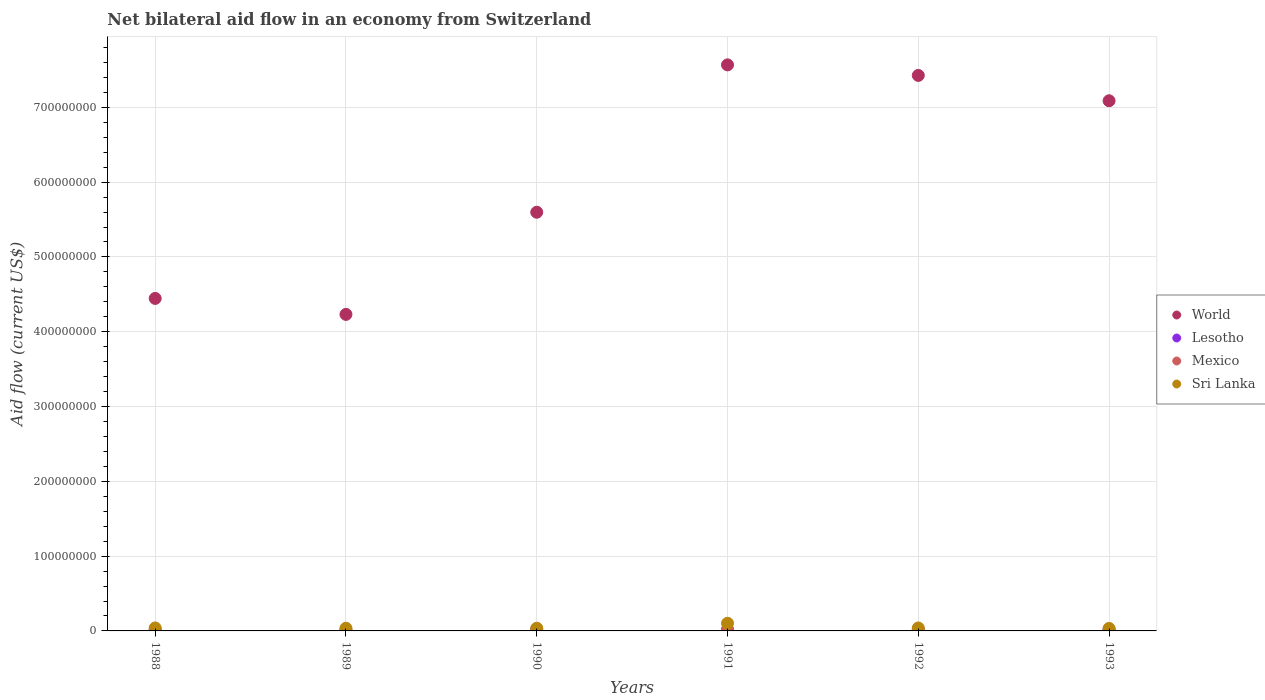How many different coloured dotlines are there?
Your response must be concise. 4. What is the net bilateral aid flow in Lesotho in 1989?
Make the answer very short. 8.60e+05. Across all years, what is the maximum net bilateral aid flow in Mexico?
Your answer should be very brief. 9.10e+05. What is the total net bilateral aid flow in World in the graph?
Provide a short and direct response. 3.64e+09. What is the difference between the net bilateral aid flow in Sri Lanka in 1991 and that in 1992?
Give a very brief answer. 6.31e+06. What is the difference between the net bilateral aid flow in World in 1993 and the net bilateral aid flow in Lesotho in 1989?
Offer a very short reply. 7.08e+08. What is the average net bilateral aid flow in World per year?
Provide a short and direct response. 6.06e+08. In the year 1993, what is the difference between the net bilateral aid flow in Mexico and net bilateral aid flow in World?
Your response must be concise. -7.09e+08. In how many years, is the net bilateral aid flow in Sri Lanka greater than 460000000 US$?
Give a very brief answer. 0. What is the ratio of the net bilateral aid flow in World in 1990 to that in 1993?
Your response must be concise. 0.79. Is the net bilateral aid flow in Sri Lanka in 1989 less than that in 1993?
Offer a very short reply. No. What is the difference between the highest and the lowest net bilateral aid flow in Sri Lanka?
Give a very brief answer. 6.93e+06. Is the sum of the net bilateral aid flow in Sri Lanka in 1988 and 1989 greater than the maximum net bilateral aid flow in Lesotho across all years?
Your answer should be compact. Yes. Is it the case that in every year, the sum of the net bilateral aid flow in Sri Lanka and net bilateral aid flow in Lesotho  is greater than the net bilateral aid flow in World?
Your answer should be compact. No. Is the net bilateral aid flow in Mexico strictly greater than the net bilateral aid flow in Sri Lanka over the years?
Offer a very short reply. No. Does the graph contain any zero values?
Make the answer very short. No. Where does the legend appear in the graph?
Your answer should be very brief. Center right. What is the title of the graph?
Make the answer very short. Net bilateral aid flow in an economy from Switzerland. What is the label or title of the X-axis?
Your response must be concise. Years. What is the label or title of the Y-axis?
Your response must be concise. Aid flow (current US$). What is the Aid flow (current US$) in World in 1988?
Your answer should be very brief. 4.45e+08. What is the Aid flow (current US$) in Lesotho in 1988?
Provide a succinct answer. 1.59e+06. What is the Aid flow (current US$) of Mexico in 1988?
Give a very brief answer. 4.80e+05. What is the Aid flow (current US$) of Sri Lanka in 1988?
Provide a short and direct response. 3.97e+06. What is the Aid flow (current US$) of World in 1989?
Make the answer very short. 4.23e+08. What is the Aid flow (current US$) in Lesotho in 1989?
Make the answer very short. 8.60e+05. What is the Aid flow (current US$) in Mexico in 1989?
Your answer should be compact. 8.80e+05. What is the Aid flow (current US$) in Sri Lanka in 1989?
Your answer should be very brief. 3.58e+06. What is the Aid flow (current US$) of World in 1990?
Give a very brief answer. 5.60e+08. What is the Aid flow (current US$) of Mexico in 1990?
Offer a very short reply. 9.10e+05. What is the Aid flow (current US$) in Sri Lanka in 1990?
Ensure brevity in your answer.  3.61e+06. What is the Aid flow (current US$) in World in 1991?
Offer a very short reply. 7.57e+08. What is the Aid flow (current US$) in Lesotho in 1991?
Offer a terse response. 1.99e+06. What is the Aid flow (current US$) in Mexico in 1991?
Offer a terse response. 3.40e+05. What is the Aid flow (current US$) in Sri Lanka in 1991?
Your answer should be compact. 1.02e+07. What is the Aid flow (current US$) of World in 1992?
Offer a terse response. 7.43e+08. What is the Aid flow (current US$) in Lesotho in 1992?
Your answer should be compact. 2.06e+06. What is the Aid flow (current US$) of Mexico in 1992?
Keep it short and to the point. 2.10e+05. What is the Aid flow (current US$) in Sri Lanka in 1992?
Provide a short and direct response. 3.94e+06. What is the Aid flow (current US$) in World in 1993?
Ensure brevity in your answer.  7.09e+08. What is the Aid flow (current US$) in Lesotho in 1993?
Provide a succinct answer. 2.02e+06. What is the Aid flow (current US$) in Sri Lanka in 1993?
Offer a terse response. 3.32e+06. Across all years, what is the maximum Aid flow (current US$) in World?
Provide a short and direct response. 7.57e+08. Across all years, what is the maximum Aid flow (current US$) of Lesotho?
Keep it short and to the point. 2.06e+06. Across all years, what is the maximum Aid flow (current US$) of Mexico?
Your response must be concise. 9.10e+05. Across all years, what is the maximum Aid flow (current US$) in Sri Lanka?
Offer a terse response. 1.02e+07. Across all years, what is the minimum Aid flow (current US$) of World?
Make the answer very short. 4.23e+08. Across all years, what is the minimum Aid flow (current US$) of Lesotho?
Your response must be concise. 8.60e+05. Across all years, what is the minimum Aid flow (current US$) of Sri Lanka?
Your answer should be compact. 3.32e+06. What is the total Aid flow (current US$) of World in the graph?
Make the answer very short. 3.64e+09. What is the total Aid flow (current US$) in Lesotho in the graph?
Your answer should be compact. 1.05e+07. What is the total Aid flow (current US$) in Mexico in the graph?
Offer a very short reply. 3.08e+06. What is the total Aid flow (current US$) of Sri Lanka in the graph?
Your answer should be compact. 2.87e+07. What is the difference between the Aid flow (current US$) in World in 1988 and that in 1989?
Provide a succinct answer. 2.14e+07. What is the difference between the Aid flow (current US$) in Lesotho in 1988 and that in 1989?
Offer a very short reply. 7.30e+05. What is the difference between the Aid flow (current US$) in Mexico in 1988 and that in 1989?
Provide a succinct answer. -4.00e+05. What is the difference between the Aid flow (current US$) of World in 1988 and that in 1990?
Provide a succinct answer. -1.15e+08. What is the difference between the Aid flow (current US$) of Lesotho in 1988 and that in 1990?
Your answer should be compact. -4.10e+05. What is the difference between the Aid flow (current US$) of Mexico in 1988 and that in 1990?
Your answer should be very brief. -4.30e+05. What is the difference between the Aid flow (current US$) in Sri Lanka in 1988 and that in 1990?
Offer a terse response. 3.60e+05. What is the difference between the Aid flow (current US$) in World in 1988 and that in 1991?
Ensure brevity in your answer.  -3.12e+08. What is the difference between the Aid flow (current US$) in Lesotho in 1988 and that in 1991?
Provide a short and direct response. -4.00e+05. What is the difference between the Aid flow (current US$) of Sri Lanka in 1988 and that in 1991?
Offer a terse response. -6.28e+06. What is the difference between the Aid flow (current US$) of World in 1988 and that in 1992?
Offer a very short reply. -2.98e+08. What is the difference between the Aid flow (current US$) in Lesotho in 1988 and that in 1992?
Your answer should be compact. -4.70e+05. What is the difference between the Aid flow (current US$) of World in 1988 and that in 1993?
Ensure brevity in your answer.  -2.64e+08. What is the difference between the Aid flow (current US$) in Lesotho in 1988 and that in 1993?
Your answer should be very brief. -4.30e+05. What is the difference between the Aid flow (current US$) of Sri Lanka in 1988 and that in 1993?
Give a very brief answer. 6.50e+05. What is the difference between the Aid flow (current US$) in World in 1989 and that in 1990?
Your response must be concise. -1.37e+08. What is the difference between the Aid flow (current US$) in Lesotho in 1989 and that in 1990?
Keep it short and to the point. -1.14e+06. What is the difference between the Aid flow (current US$) of Sri Lanka in 1989 and that in 1990?
Your response must be concise. -3.00e+04. What is the difference between the Aid flow (current US$) in World in 1989 and that in 1991?
Your answer should be very brief. -3.34e+08. What is the difference between the Aid flow (current US$) in Lesotho in 1989 and that in 1991?
Provide a succinct answer. -1.13e+06. What is the difference between the Aid flow (current US$) in Mexico in 1989 and that in 1991?
Make the answer very short. 5.40e+05. What is the difference between the Aid flow (current US$) of Sri Lanka in 1989 and that in 1991?
Offer a very short reply. -6.67e+06. What is the difference between the Aid flow (current US$) of World in 1989 and that in 1992?
Offer a very short reply. -3.20e+08. What is the difference between the Aid flow (current US$) of Lesotho in 1989 and that in 1992?
Keep it short and to the point. -1.20e+06. What is the difference between the Aid flow (current US$) of Mexico in 1989 and that in 1992?
Your answer should be compact. 6.70e+05. What is the difference between the Aid flow (current US$) of Sri Lanka in 1989 and that in 1992?
Your answer should be compact. -3.60e+05. What is the difference between the Aid flow (current US$) of World in 1989 and that in 1993?
Make the answer very short. -2.86e+08. What is the difference between the Aid flow (current US$) of Lesotho in 1989 and that in 1993?
Your response must be concise. -1.16e+06. What is the difference between the Aid flow (current US$) in Mexico in 1989 and that in 1993?
Your answer should be very brief. 6.20e+05. What is the difference between the Aid flow (current US$) of World in 1990 and that in 1991?
Your response must be concise. -1.97e+08. What is the difference between the Aid flow (current US$) in Lesotho in 1990 and that in 1991?
Offer a very short reply. 10000. What is the difference between the Aid flow (current US$) in Mexico in 1990 and that in 1991?
Keep it short and to the point. 5.70e+05. What is the difference between the Aid flow (current US$) of Sri Lanka in 1990 and that in 1991?
Make the answer very short. -6.64e+06. What is the difference between the Aid flow (current US$) of World in 1990 and that in 1992?
Give a very brief answer. -1.83e+08. What is the difference between the Aid flow (current US$) of Lesotho in 1990 and that in 1992?
Ensure brevity in your answer.  -6.00e+04. What is the difference between the Aid flow (current US$) of Mexico in 1990 and that in 1992?
Ensure brevity in your answer.  7.00e+05. What is the difference between the Aid flow (current US$) in Sri Lanka in 1990 and that in 1992?
Provide a short and direct response. -3.30e+05. What is the difference between the Aid flow (current US$) in World in 1990 and that in 1993?
Your answer should be very brief. -1.49e+08. What is the difference between the Aid flow (current US$) of Mexico in 1990 and that in 1993?
Make the answer very short. 6.50e+05. What is the difference between the Aid flow (current US$) of World in 1991 and that in 1992?
Your answer should be compact. 1.41e+07. What is the difference between the Aid flow (current US$) in Sri Lanka in 1991 and that in 1992?
Your answer should be compact. 6.31e+06. What is the difference between the Aid flow (current US$) in World in 1991 and that in 1993?
Make the answer very short. 4.80e+07. What is the difference between the Aid flow (current US$) in Lesotho in 1991 and that in 1993?
Offer a terse response. -3.00e+04. What is the difference between the Aid flow (current US$) of Sri Lanka in 1991 and that in 1993?
Provide a short and direct response. 6.93e+06. What is the difference between the Aid flow (current US$) in World in 1992 and that in 1993?
Your answer should be very brief. 3.39e+07. What is the difference between the Aid flow (current US$) of Sri Lanka in 1992 and that in 1993?
Provide a short and direct response. 6.20e+05. What is the difference between the Aid flow (current US$) in World in 1988 and the Aid flow (current US$) in Lesotho in 1989?
Provide a short and direct response. 4.44e+08. What is the difference between the Aid flow (current US$) of World in 1988 and the Aid flow (current US$) of Mexico in 1989?
Your answer should be compact. 4.44e+08. What is the difference between the Aid flow (current US$) of World in 1988 and the Aid flow (current US$) of Sri Lanka in 1989?
Ensure brevity in your answer.  4.41e+08. What is the difference between the Aid flow (current US$) of Lesotho in 1988 and the Aid flow (current US$) of Mexico in 1989?
Offer a very short reply. 7.10e+05. What is the difference between the Aid flow (current US$) in Lesotho in 1988 and the Aid flow (current US$) in Sri Lanka in 1989?
Offer a very short reply. -1.99e+06. What is the difference between the Aid flow (current US$) of Mexico in 1988 and the Aid flow (current US$) of Sri Lanka in 1989?
Give a very brief answer. -3.10e+06. What is the difference between the Aid flow (current US$) of World in 1988 and the Aid flow (current US$) of Lesotho in 1990?
Your answer should be compact. 4.43e+08. What is the difference between the Aid flow (current US$) in World in 1988 and the Aid flow (current US$) in Mexico in 1990?
Give a very brief answer. 4.44e+08. What is the difference between the Aid flow (current US$) in World in 1988 and the Aid flow (current US$) in Sri Lanka in 1990?
Your answer should be compact. 4.41e+08. What is the difference between the Aid flow (current US$) of Lesotho in 1988 and the Aid flow (current US$) of Mexico in 1990?
Ensure brevity in your answer.  6.80e+05. What is the difference between the Aid flow (current US$) in Lesotho in 1988 and the Aid flow (current US$) in Sri Lanka in 1990?
Your response must be concise. -2.02e+06. What is the difference between the Aid flow (current US$) of Mexico in 1988 and the Aid flow (current US$) of Sri Lanka in 1990?
Give a very brief answer. -3.13e+06. What is the difference between the Aid flow (current US$) of World in 1988 and the Aid flow (current US$) of Lesotho in 1991?
Keep it short and to the point. 4.43e+08. What is the difference between the Aid flow (current US$) of World in 1988 and the Aid flow (current US$) of Mexico in 1991?
Give a very brief answer. 4.44e+08. What is the difference between the Aid flow (current US$) in World in 1988 and the Aid flow (current US$) in Sri Lanka in 1991?
Offer a very short reply. 4.34e+08. What is the difference between the Aid flow (current US$) in Lesotho in 1988 and the Aid flow (current US$) in Mexico in 1991?
Your answer should be compact. 1.25e+06. What is the difference between the Aid flow (current US$) of Lesotho in 1988 and the Aid flow (current US$) of Sri Lanka in 1991?
Ensure brevity in your answer.  -8.66e+06. What is the difference between the Aid flow (current US$) in Mexico in 1988 and the Aid flow (current US$) in Sri Lanka in 1991?
Provide a succinct answer. -9.77e+06. What is the difference between the Aid flow (current US$) of World in 1988 and the Aid flow (current US$) of Lesotho in 1992?
Your answer should be compact. 4.42e+08. What is the difference between the Aid flow (current US$) of World in 1988 and the Aid flow (current US$) of Mexico in 1992?
Provide a succinct answer. 4.44e+08. What is the difference between the Aid flow (current US$) in World in 1988 and the Aid flow (current US$) in Sri Lanka in 1992?
Provide a short and direct response. 4.41e+08. What is the difference between the Aid flow (current US$) in Lesotho in 1988 and the Aid flow (current US$) in Mexico in 1992?
Provide a succinct answer. 1.38e+06. What is the difference between the Aid flow (current US$) in Lesotho in 1988 and the Aid flow (current US$) in Sri Lanka in 1992?
Offer a terse response. -2.35e+06. What is the difference between the Aid flow (current US$) of Mexico in 1988 and the Aid flow (current US$) of Sri Lanka in 1992?
Your answer should be very brief. -3.46e+06. What is the difference between the Aid flow (current US$) of World in 1988 and the Aid flow (current US$) of Lesotho in 1993?
Your answer should be compact. 4.43e+08. What is the difference between the Aid flow (current US$) of World in 1988 and the Aid flow (current US$) of Mexico in 1993?
Your answer should be compact. 4.44e+08. What is the difference between the Aid flow (current US$) of World in 1988 and the Aid flow (current US$) of Sri Lanka in 1993?
Keep it short and to the point. 4.41e+08. What is the difference between the Aid flow (current US$) of Lesotho in 1988 and the Aid flow (current US$) of Mexico in 1993?
Keep it short and to the point. 1.33e+06. What is the difference between the Aid flow (current US$) in Lesotho in 1988 and the Aid flow (current US$) in Sri Lanka in 1993?
Your answer should be very brief. -1.73e+06. What is the difference between the Aid flow (current US$) of Mexico in 1988 and the Aid flow (current US$) of Sri Lanka in 1993?
Your answer should be compact. -2.84e+06. What is the difference between the Aid flow (current US$) in World in 1989 and the Aid flow (current US$) in Lesotho in 1990?
Ensure brevity in your answer.  4.21e+08. What is the difference between the Aid flow (current US$) of World in 1989 and the Aid flow (current US$) of Mexico in 1990?
Your response must be concise. 4.22e+08. What is the difference between the Aid flow (current US$) of World in 1989 and the Aid flow (current US$) of Sri Lanka in 1990?
Provide a short and direct response. 4.20e+08. What is the difference between the Aid flow (current US$) in Lesotho in 1989 and the Aid flow (current US$) in Mexico in 1990?
Give a very brief answer. -5.00e+04. What is the difference between the Aid flow (current US$) of Lesotho in 1989 and the Aid flow (current US$) of Sri Lanka in 1990?
Your answer should be very brief. -2.75e+06. What is the difference between the Aid flow (current US$) of Mexico in 1989 and the Aid flow (current US$) of Sri Lanka in 1990?
Give a very brief answer. -2.73e+06. What is the difference between the Aid flow (current US$) in World in 1989 and the Aid flow (current US$) in Lesotho in 1991?
Provide a succinct answer. 4.21e+08. What is the difference between the Aid flow (current US$) in World in 1989 and the Aid flow (current US$) in Mexico in 1991?
Offer a terse response. 4.23e+08. What is the difference between the Aid flow (current US$) in World in 1989 and the Aid flow (current US$) in Sri Lanka in 1991?
Provide a short and direct response. 4.13e+08. What is the difference between the Aid flow (current US$) in Lesotho in 1989 and the Aid flow (current US$) in Mexico in 1991?
Offer a very short reply. 5.20e+05. What is the difference between the Aid flow (current US$) of Lesotho in 1989 and the Aid flow (current US$) of Sri Lanka in 1991?
Your answer should be compact. -9.39e+06. What is the difference between the Aid flow (current US$) in Mexico in 1989 and the Aid flow (current US$) in Sri Lanka in 1991?
Offer a terse response. -9.37e+06. What is the difference between the Aid flow (current US$) in World in 1989 and the Aid flow (current US$) in Lesotho in 1992?
Provide a succinct answer. 4.21e+08. What is the difference between the Aid flow (current US$) of World in 1989 and the Aid flow (current US$) of Mexico in 1992?
Keep it short and to the point. 4.23e+08. What is the difference between the Aid flow (current US$) in World in 1989 and the Aid flow (current US$) in Sri Lanka in 1992?
Your answer should be compact. 4.19e+08. What is the difference between the Aid flow (current US$) of Lesotho in 1989 and the Aid flow (current US$) of Mexico in 1992?
Give a very brief answer. 6.50e+05. What is the difference between the Aid flow (current US$) in Lesotho in 1989 and the Aid flow (current US$) in Sri Lanka in 1992?
Your answer should be very brief. -3.08e+06. What is the difference between the Aid flow (current US$) of Mexico in 1989 and the Aid flow (current US$) of Sri Lanka in 1992?
Ensure brevity in your answer.  -3.06e+06. What is the difference between the Aid flow (current US$) of World in 1989 and the Aid flow (current US$) of Lesotho in 1993?
Give a very brief answer. 4.21e+08. What is the difference between the Aid flow (current US$) in World in 1989 and the Aid flow (current US$) in Mexico in 1993?
Your answer should be very brief. 4.23e+08. What is the difference between the Aid flow (current US$) in World in 1989 and the Aid flow (current US$) in Sri Lanka in 1993?
Your response must be concise. 4.20e+08. What is the difference between the Aid flow (current US$) in Lesotho in 1989 and the Aid flow (current US$) in Sri Lanka in 1993?
Keep it short and to the point. -2.46e+06. What is the difference between the Aid flow (current US$) in Mexico in 1989 and the Aid flow (current US$) in Sri Lanka in 1993?
Your answer should be very brief. -2.44e+06. What is the difference between the Aid flow (current US$) in World in 1990 and the Aid flow (current US$) in Lesotho in 1991?
Give a very brief answer. 5.58e+08. What is the difference between the Aid flow (current US$) of World in 1990 and the Aid flow (current US$) of Mexico in 1991?
Offer a terse response. 5.59e+08. What is the difference between the Aid flow (current US$) of World in 1990 and the Aid flow (current US$) of Sri Lanka in 1991?
Offer a very short reply. 5.50e+08. What is the difference between the Aid flow (current US$) in Lesotho in 1990 and the Aid flow (current US$) in Mexico in 1991?
Provide a short and direct response. 1.66e+06. What is the difference between the Aid flow (current US$) in Lesotho in 1990 and the Aid flow (current US$) in Sri Lanka in 1991?
Your answer should be very brief. -8.25e+06. What is the difference between the Aid flow (current US$) of Mexico in 1990 and the Aid flow (current US$) of Sri Lanka in 1991?
Give a very brief answer. -9.34e+06. What is the difference between the Aid flow (current US$) of World in 1990 and the Aid flow (current US$) of Lesotho in 1992?
Give a very brief answer. 5.58e+08. What is the difference between the Aid flow (current US$) in World in 1990 and the Aid flow (current US$) in Mexico in 1992?
Provide a short and direct response. 5.60e+08. What is the difference between the Aid flow (current US$) in World in 1990 and the Aid flow (current US$) in Sri Lanka in 1992?
Your response must be concise. 5.56e+08. What is the difference between the Aid flow (current US$) of Lesotho in 1990 and the Aid flow (current US$) of Mexico in 1992?
Your answer should be compact. 1.79e+06. What is the difference between the Aid flow (current US$) in Lesotho in 1990 and the Aid flow (current US$) in Sri Lanka in 1992?
Provide a succinct answer. -1.94e+06. What is the difference between the Aid flow (current US$) of Mexico in 1990 and the Aid flow (current US$) of Sri Lanka in 1992?
Your answer should be very brief. -3.03e+06. What is the difference between the Aid flow (current US$) of World in 1990 and the Aid flow (current US$) of Lesotho in 1993?
Ensure brevity in your answer.  5.58e+08. What is the difference between the Aid flow (current US$) in World in 1990 and the Aid flow (current US$) in Mexico in 1993?
Make the answer very short. 5.60e+08. What is the difference between the Aid flow (current US$) in World in 1990 and the Aid flow (current US$) in Sri Lanka in 1993?
Give a very brief answer. 5.56e+08. What is the difference between the Aid flow (current US$) in Lesotho in 1990 and the Aid flow (current US$) in Mexico in 1993?
Ensure brevity in your answer.  1.74e+06. What is the difference between the Aid flow (current US$) of Lesotho in 1990 and the Aid flow (current US$) of Sri Lanka in 1993?
Your response must be concise. -1.32e+06. What is the difference between the Aid flow (current US$) in Mexico in 1990 and the Aid flow (current US$) in Sri Lanka in 1993?
Your answer should be very brief. -2.41e+06. What is the difference between the Aid flow (current US$) of World in 1991 and the Aid flow (current US$) of Lesotho in 1992?
Your answer should be very brief. 7.55e+08. What is the difference between the Aid flow (current US$) of World in 1991 and the Aid flow (current US$) of Mexico in 1992?
Give a very brief answer. 7.57e+08. What is the difference between the Aid flow (current US$) of World in 1991 and the Aid flow (current US$) of Sri Lanka in 1992?
Provide a short and direct response. 7.53e+08. What is the difference between the Aid flow (current US$) of Lesotho in 1991 and the Aid flow (current US$) of Mexico in 1992?
Ensure brevity in your answer.  1.78e+06. What is the difference between the Aid flow (current US$) in Lesotho in 1991 and the Aid flow (current US$) in Sri Lanka in 1992?
Provide a succinct answer. -1.95e+06. What is the difference between the Aid flow (current US$) of Mexico in 1991 and the Aid flow (current US$) of Sri Lanka in 1992?
Keep it short and to the point. -3.60e+06. What is the difference between the Aid flow (current US$) in World in 1991 and the Aid flow (current US$) in Lesotho in 1993?
Offer a terse response. 7.55e+08. What is the difference between the Aid flow (current US$) in World in 1991 and the Aid flow (current US$) in Mexico in 1993?
Your answer should be compact. 7.57e+08. What is the difference between the Aid flow (current US$) of World in 1991 and the Aid flow (current US$) of Sri Lanka in 1993?
Keep it short and to the point. 7.53e+08. What is the difference between the Aid flow (current US$) in Lesotho in 1991 and the Aid flow (current US$) in Mexico in 1993?
Your response must be concise. 1.73e+06. What is the difference between the Aid flow (current US$) of Lesotho in 1991 and the Aid flow (current US$) of Sri Lanka in 1993?
Your answer should be very brief. -1.33e+06. What is the difference between the Aid flow (current US$) of Mexico in 1991 and the Aid flow (current US$) of Sri Lanka in 1993?
Offer a very short reply. -2.98e+06. What is the difference between the Aid flow (current US$) in World in 1992 and the Aid flow (current US$) in Lesotho in 1993?
Your answer should be very brief. 7.41e+08. What is the difference between the Aid flow (current US$) of World in 1992 and the Aid flow (current US$) of Mexico in 1993?
Give a very brief answer. 7.42e+08. What is the difference between the Aid flow (current US$) of World in 1992 and the Aid flow (current US$) of Sri Lanka in 1993?
Give a very brief answer. 7.39e+08. What is the difference between the Aid flow (current US$) in Lesotho in 1992 and the Aid flow (current US$) in Mexico in 1993?
Your answer should be compact. 1.80e+06. What is the difference between the Aid flow (current US$) of Lesotho in 1992 and the Aid flow (current US$) of Sri Lanka in 1993?
Provide a short and direct response. -1.26e+06. What is the difference between the Aid flow (current US$) of Mexico in 1992 and the Aid flow (current US$) of Sri Lanka in 1993?
Your response must be concise. -3.11e+06. What is the average Aid flow (current US$) of World per year?
Give a very brief answer. 6.06e+08. What is the average Aid flow (current US$) in Lesotho per year?
Provide a succinct answer. 1.75e+06. What is the average Aid flow (current US$) of Mexico per year?
Offer a terse response. 5.13e+05. What is the average Aid flow (current US$) of Sri Lanka per year?
Provide a short and direct response. 4.78e+06. In the year 1988, what is the difference between the Aid flow (current US$) of World and Aid flow (current US$) of Lesotho?
Offer a very short reply. 4.43e+08. In the year 1988, what is the difference between the Aid flow (current US$) of World and Aid flow (current US$) of Mexico?
Your response must be concise. 4.44e+08. In the year 1988, what is the difference between the Aid flow (current US$) of World and Aid flow (current US$) of Sri Lanka?
Your answer should be very brief. 4.41e+08. In the year 1988, what is the difference between the Aid flow (current US$) in Lesotho and Aid flow (current US$) in Mexico?
Give a very brief answer. 1.11e+06. In the year 1988, what is the difference between the Aid flow (current US$) of Lesotho and Aid flow (current US$) of Sri Lanka?
Give a very brief answer. -2.38e+06. In the year 1988, what is the difference between the Aid flow (current US$) in Mexico and Aid flow (current US$) in Sri Lanka?
Make the answer very short. -3.49e+06. In the year 1989, what is the difference between the Aid flow (current US$) in World and Aid flow (current US$) in Lesotho?
Give a very brief answer. 4.22e+08. In the year 1989, what is the difference between the Aid flow (current US$) in World and Aid flow (current US$) in Mexico?
Your response must be concise. 4.22e+08. In the year 1989, what is the difference between the Aid flow (current US$) of World and Aid flow (current US$) of Sri Lanka?
Your answer should be very brief. 4.20e+08. In the year 1989, what is the difference between the Aid flow (current US$) of Lesotho and Aid flow (current US$) of Mexico?
Provide a short and direct response. -2.00e+04. In the year 1989, what is the difference between the Aid flow (current US$) of Lesotho and Aid flow (current US$) of Sri Lanka?
Your answer should be very brief. -2.72e+06. In the year 1989, what is the difference between the Aid flow (current US$) of Mexico and Aid flow (current US$) of Sri Lanka?
Provide a short and direct response. -2.70e+06. In the year 1990, what is the difference between the Aid flow (current US$) of World and Aid flow (current US$) of Lesotho?
Provide a short and direct response. 5.58e+08. In the year 1990, what is the difference between the Aid flow (current US$) in World and Aid flow (current US$) in Mexico?
Your answer should be compact. 5.59e+08. In the year 1990, what is the difference between the Aid flow (current US$) in World and Aid flow (current US$) in Sri Lanka?
Provide a succinct answer. 5.56e+08. In the year 1990, what is the difference between the Aid flow (current US$) of Lesotho and Aid flow (current US$) of Mexico?
Your answer should be very brief. 1.09e+06. In the year 1990, what is the difference between the Aid flow (current US$) in Lesotho and Aid flow (current US$) in Sri Lanka?
Your answer should be compact. -1.61e+06. In the year 1990, what is the difference between the Aid flow (current US$) in Mexico and Aid flow (current US$) in Sri Lanka?
Make the answer very short. -2.70e+06. In the year 1991, what is the difference between the Aid flow (current US$) in World and Aid flow (current US$) in Lesotho?
Your answer should be very brief. 7.55e+08. In the year 1991, what is the difference between the Aid flow (current US$) of World and Aid flow (current US$) of Mexico?
Make the answer very short. 7.56e+08. In the year 1991, what is the difference between the Aid flow (current US$) of World and Aid flow (current US$) of Sri Lanka?
Ensure brevity in your answer.  7.47e+08. In the year 1991, what is the difference between the Aid flow (current US$) in Lesotho and Aid flow (current US$) in Mexico?
Provide a short and direct response. 1.65e+06. In the year 1991, what is the difference between the Aid flow (current US$) in Lesotho and Aid flow (current US$) in Sri Lanka?
Offer a very short reply. -8.26e+06. In the year 1991, what is the difference between the Aid flow (current US$) in Mexico and Aid flow (current US$) in Sri Lanka?
Your answer should be compact. -9.91e+06. In the year 1992, what is the difference between the Aid flow (current US$) of World and Aid flow (current US$) of Lesotho?
Make the answer very short. 7.41e+08. In the year 1992, what is the difference between the Aid flow (current US$) of World and Aid flow (current US$) of Mexico?
Offer a terse response. 7.42e+08. In the year 1992, what is the difference between the Aid flow (current US$) of World and Aid flow (current US$) of Sri Lanka?
Your response must be concise. 7.39e+08. In the year 1992, what is the difference between the Aid flow (current US$) in Lesotho and Aid flow (current US$) in Mexico?
Your answer should be very brief. 1.85e+06. In the year 1992, what is the difference between the Aid flow (current US$) in Lesotho and Aid flow (current US$) in Sri Lanka?
Your answer should be compact. -1.88e+06. In the year 1992, what is the difference between the Aid flow (current US$) of Mexico and Aid flow (current US$) of Sri Lanka?
Provide a succinct answer. -3.73e+06. In the year 1993, what is the difference between the Aid flow (current US$) in World and Aid flow (current US$) in Lesotho?
Provide a succinct answer. 7.07e+08. In the year 1993, what is the difference between the Aid flow (current US$) of World and Aid flow (current US$) of Mexico?
Provide a succinct answer. 7.09e+08. In the year 1993, what is the difference between the Aid flow (current US$) of World and Aid flow (current US$) of Sri Lanka?
Ensure brevity in your answer.  7.06e+08. In the year 1993, what is the difference between the Aid flow (current US$) of Lesotho and Aid flow (current US$) of Mexico?
Keep it short and to the point. 1.76e+06. In the year 1993, what is the difference between the Aid flow (current US$) in Lesotho and Aid flow (current US$) in Sri Lanka?
Give a very brief answer. -1.30e+06. In the year 1993, what is the difference between the Aid flow (current US$) of Mexico and Aid flow (current US$) of Sri Lanka?
Give a very brief answer. -3.06e+06. What is the ratio of the Aid flow (current US$) of World in 1988 to that in 1989?
Offer a terse response. 1.05. What is the ratio of the Aid flow (current US$) in Lesotho in 1988 to that in 1989?
Provide a short and direct response. 1.85. What is the ratio of the Aid flow (current US$) in Mexico in 1988 to that in 1989?
Your response must be concise. 0.55. What is the ratio of the Aid flow (current US$) in Sri Lanka in 1988 to that in 1989?
Provide a short and direct response. 1.11. What is the ratio of the Aid flow (current US$) of World in 1988 to that in 1990?
Offer a terse response. 0.79. What is the ratio of the Aid flow (current US$) in Lesotho in 1988 to that in 1990?
Your answer should be compact. 0.8. What is the ratio of the Aid flow (current US$) of Mexico in 1988 to that in 1990?
Offer a very short reply. 0.53. What is the ratio of the Aid flow (current US$) in Sri Lanka in 1988 to that in 1990?
Offer a terse response. 1.1. What is the ratio of the Aid flow (current US$) in World in 1988 to that in 1991?
Make the answer very short. 0.59. What is the ratio of the Aid flow (current US$) of Lesotho in 1988 to that in 1991?
Your answer should be compact. 0.8. What is the ratio of the Aid flow (current US$) in Mexico in 1988 to that in 1991?
Provide a short and direct response. 1.41. What is the ratio of the Aid flow (current US$) in Sri Lanka in 1988 to that in 1991?
Your answer should be compact. 0.39. What is the ratio of the Aid flow (current US$) of World in 1988 to that in 1992?
Make the answer very short. 0.6. What is the ratio of the Aid flow (current US$) in Lesotho in 1988 to that in 1992?
Make the answer very short. 0.77. What is the ratio of the Aid flow (current US$) in Mexico in 1988 to that in 1992?
Offer a terse response. 2.29. What is the ratio of the Aid flow (current US$) of Sri Lanka in 1988 to that in 1992?
Keep it short and to the point. 1.01. What is the ratio of the Aid flow (current US$) in World in 1988 to that in 1993?
Offer a terse response. 0.63. What is the ratio of the Aid flow (current US$) of Lesotho in 1988 to that in 1993?
Provide a short and direct response. 0.79. What is the ratio of the Aid flow (current US$) of Mexico in 1988 to that in 1993?
Ensure brevity in your answer.  1.85. What is the ratio of the Aid flow (current US$) in Sri Lanka in 1988 to that in 1993?
Ensure brevity in your answer.  1.2. What is the ratio of the Aid flow (current US$) of World in 1989 to that in 1990?
Ensure brevity in your answer.  0.76. What is the ratio of the Aid flow (current US$) in Lesotho in 1989 to that in 1990?
Provide a succinct answer. 0.43. What is the ratio of the Aid flow (current US$) of Mexico in 1989 to that in 1990?
Your answer should be compact. 0.97. What is the ratio of the Aid flow (current US$) of World in 1989 to that in 1991?
Offer a terse response. 0.56. What is the ratio of the Aid flow (current US$) of Lesotho in 1989 to that in 1991?
Offer a very short reply. 0.43. What is the ratio of the Aid flow (current US$) in Mexico in 1989 to that in 1991?
Your answer should be compact. 2.59. What is the ratio of the Aid flow (current US$) in Sri Lanka in 1989 to that in 1991?
Offer a terse response. 0.35. What is the ratio of the Aid flow (current US$) in World in 1989 to that in 1992?
Make the answer very short. 0.57. What is the ratio of the Aid flow (current US$) of Lesotho in 1989 to that in 1992?
Provide a succinct answer. 0.42. What is the ratio of the Aid flow (current US$) in Mexico in 1989 to that in 1992?
Provide a short and direct response. 4.19. What is the ratio of the Aid flow (current US$) in Sri Lanka in 1989 to that in 1992?
Offer a terse response. 0.91. What is the ratio of the Aid flow (current US$) in World in 1989 to that in 1993?
Ensure brevity in your answer.  0.6. What is the ratio of the Aid flow (current US$) in Lesotho in 1989 to that in 1993?
Your response must be concise. 0.43. What is the ratio of the Aid flow (current US$) of Mexico in 1989 to that in 1993?
Offer a very short reply. 3.38. What is the ratio of the Aid flow (current US$) in Sri Lanka in 1989 to that in 1993?
Offer a very short reply. 1.08. What is the ratio of the Aid flow (current US$) in World in 1990 to that in 1991?
Your answer should be compact. 0.74. What is the ratio of the Aid flow (current US$) of Mexico in 1990 to that in 1991?
Your answer should be compact. 2.68. What is the ratio of the Aid flow (current US$) of Sri Lanka in 1990 to that in 1991?
Ensure brevity in your answer.  0.35. What is the ratio of the Aid flow (current US$) in World in 1990 to that in 1992?
Keep it short and to the point. 0.75. What is the ratio of the Aid flow (current US$) of Lesotho in 1990 to that in 1992?
Keep it short and to the point. 0.97. What is the ratio of the Aid flow (current US$) of Mexico in 1990 to that in 1992?
Provide a short and direct response. 4.33. What is the ratio of the Aid flow (current US$) of Sri Lanka in 1990 to that in 1992?
Give a very brief answer. 0.92. What is the ratio of the Aid flow (current US$) of World in 1990 to that in 1993?
Provide a short and direct response. 0.79. What is the ratio of the Aid flow (current US$) in Lesotho in 1990 to that in 1993?
Ensure brevity in your answer.  0.99. What is the ratio of the Aid flow (current US$) of Mexico in 1990 to that in 1993?
Ensure brevity in your answer.  3.5. What is the ratio of the Aid flow (current US$) in Sri Lanka in 1990 to that in 1993?
Offer a terse response. 1.09. What is the ratio of the Aid flow (current US$) of Mexico in 1991 to that in 1992?
Give a very brief answer. 1.62. What is the ratio of the Aid flow (current US$) of Sri Lanka in 1991 to that in 1992?
Your answer should be compact. 2.6. What is the ratio of the Aid flow (current US$) of World in 1991 to that in 1993?
Offer a very short reply. 1.07. What is the ratio of the Aid flow (current US$) in Lesotho in 1991 to that in 1993?
Keep it short and to the point. 0.99. What is the ratio of the Aid flow (current US$) of Mexico in 1991 to that in 1993?
Offer a terse response. 1.31. What is the ratio of the Aid flow (current US$) of Sri Lanka in 1991 to that in 1993?
Ensure brevity in your answer.  3.09. What is the ratio of the Aid flow (current US$) in World in 1992 to that in 1993?
Your answer should be compact. 1.05. What is the ratio of the Aid flow (current US$) in Lesotho in 1992 to that in 1993?
Your response must be concise. 1.02. What is the ratio of the Aid flow (current US$) of Mexico in 1992 to that in 1993?
Provide a succinct answer. 0.81. What is the ratio of the Aid flow (current US$) in Sri Lanka in 1992 to that in 1993?
Your answer should be very brief. 1.19. What is the difference between the highest and the second highest Aid flow (current US$) of World?
Make the answer very short. 1.41e+07. What is the difference between the highest and the second highest Aid flow (current US$) in Lesotho?
Your answer should be compact. 4.00e+04. What is the difference between the highest and the second highest Aid flow (current US$) in Sri Lanka?
Your answer should be compact. 6.28e+06. What is the difference between the highest and the lowest Aid flow (current US$) of World?
Offer a terse response. 3.34e+08. What is the difference between the highest and the lowest Aid flow (current US$) in Lesotho?
Make the answer very short. 1.20e+06. What is the difference between the highest and the lowest Aid flow (current US$) of Mexico?
Make the answer very short. 7.00e+05. What is the difference between the highest and the lowest Aid flow (current US$) of Sri Lanka?
Your answer should be very brief. 6.93e+06. 